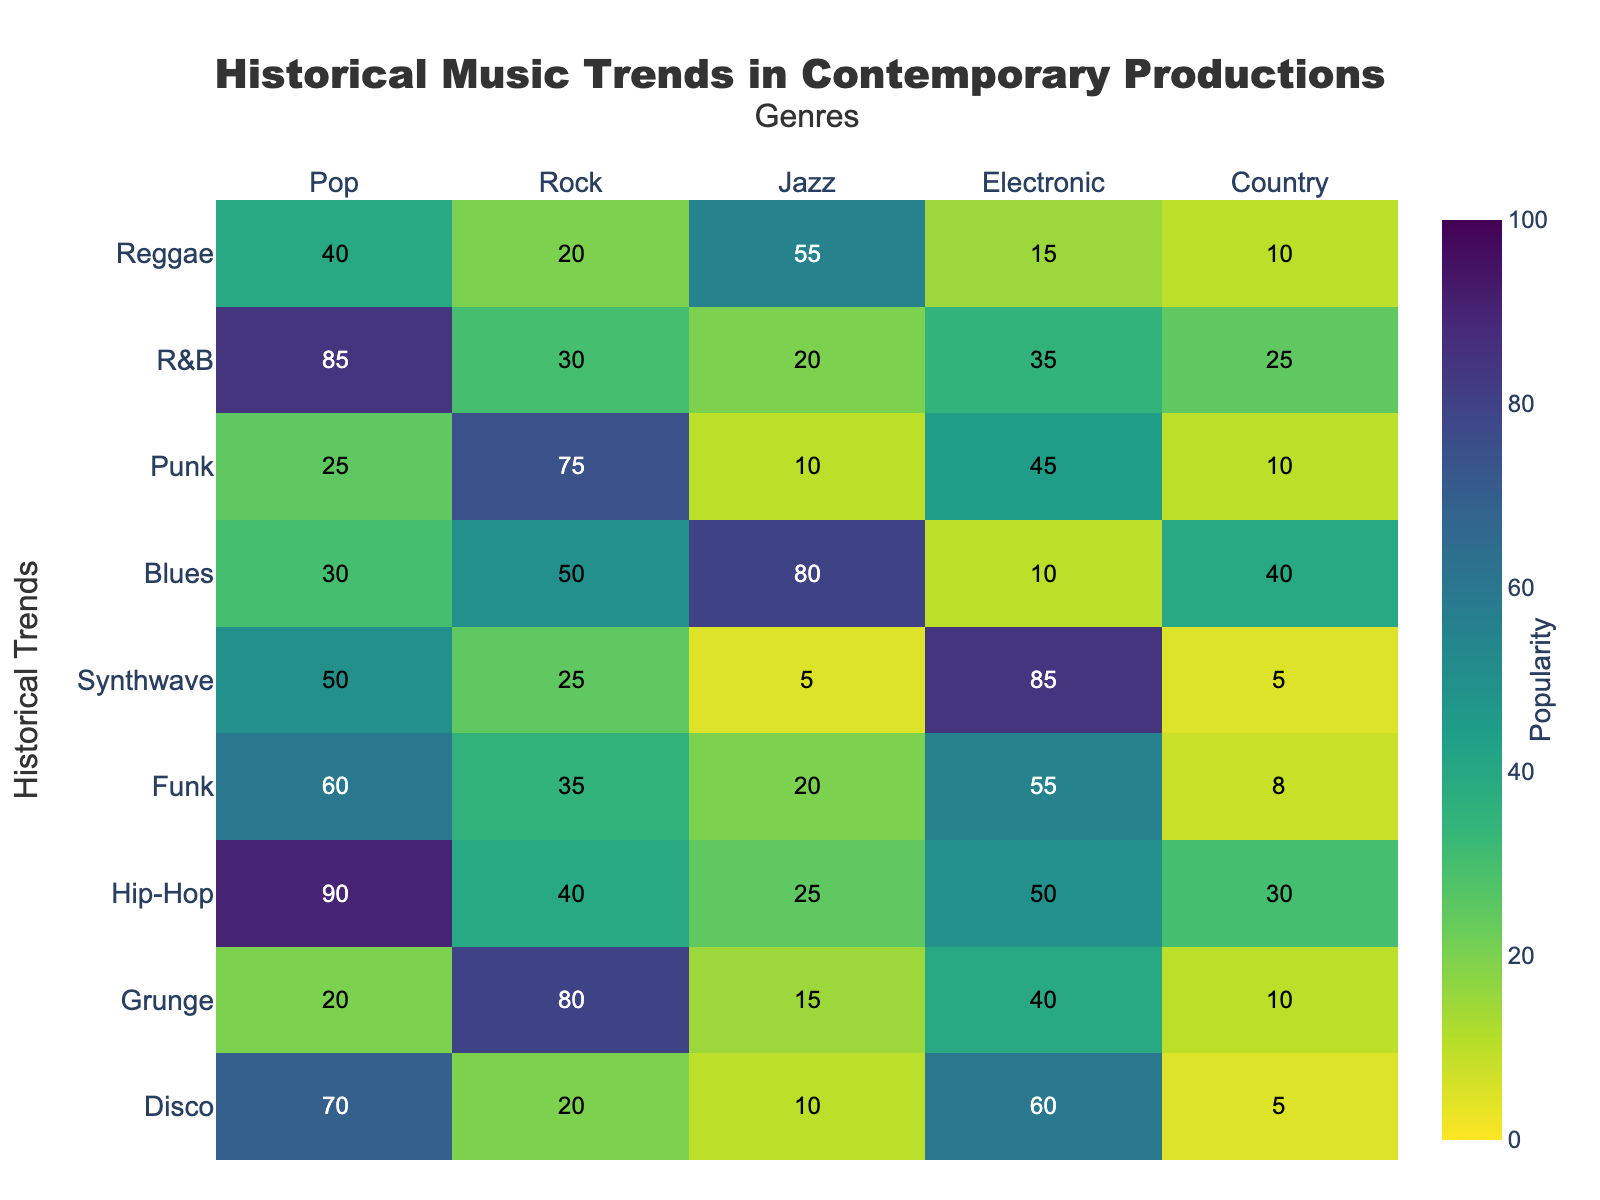What is the popularity of Hip-Hop in Rock? The popularity of Hip-Hop in Rock is represented by the cell in the heatmap where the row for Hip-Hop intersects with the column for Rock. The figure indicates a value of 40.
Answer: 40 What historical trend has the highest popularity in Pop music? To determine this, look for the highest value in the Pop column of the heatmap. The highest number is 90, corresponding to Hip-Hop.
Answer: Hip-Hop Which genre has the lowest popularity of Synthwave? Check the values in the Synthwave row across different genres to find the lowest number. The lowest value is 5, found in both Jazz and Country.
Answer: Jazz and Country What is the average popularity of Disco across all genres? Add the popularity values of Disco across all genres and divide by the number of genres: (70+20+10+60+5)/5 = 165/5 = 33.
Answer: 33 How does the popularity of Reggae in Jazz compare to its popularity in Electronic? Locate the popularity values of Reggae in Jazz and Electronic. The value for Jazz is 55 and for Electronic is 15. Reggae is more popular in Jazz than in Electronic.
Answer: More popular in Jazz Which genre has the highest popularity of Blues? Look across the Blues row to identify the highest value, which is 80 in Jazz.
Answer: Jazz What is the total popularity of Funk in Pop and Electronic combined? Add the values of Funk in Pop and Electronic: 60 (Pop) + 55 (Electronic) = 115.
Answer: 115 Is the popularity of R&B in Pop higher than in Country? Compare the values of R&B in Pop and Country. The value for Pop is 85, and for Country, it is 25. Yes, R&B is more popular in Pop.
Answer: Yes What is the difference in popularity of Punk between Rock and Pop? Subtract the popularity of Punk in Pop from its value in Rock: 75 (Rock) - 25 (Pop) = 50.
Answer: 50 